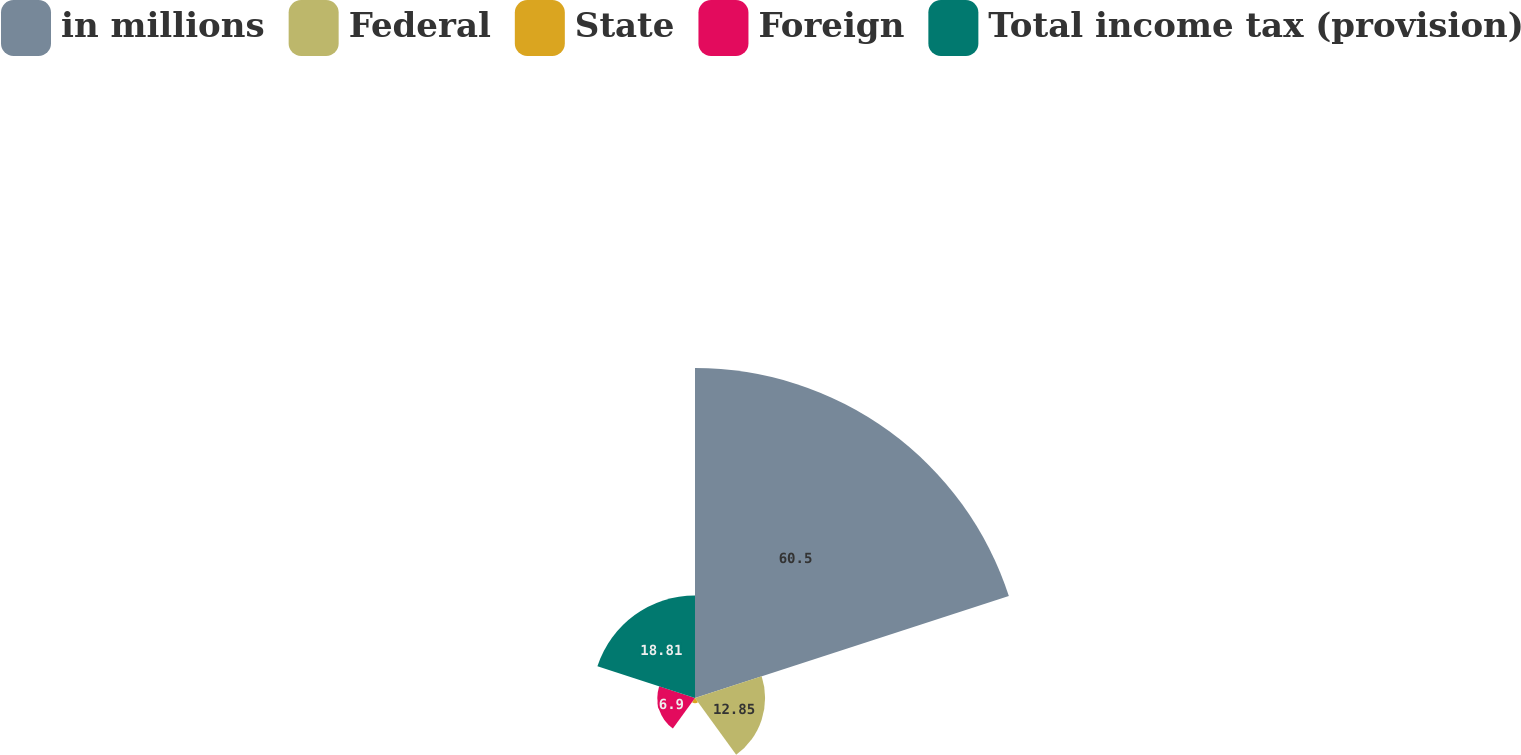Convert chart. <chart><loc_0><loc_0><loc_500><loc_500><pie_chart><fcel>in millions<fcel>Federal<fcel>State<fcel>Foreign<fcel>Total income tax (provision)<nl><fcel>60.5%<fcel>12.85%<fcel>0.94%<fcel>6.9%<fcel>18.81%<nl></chart> 